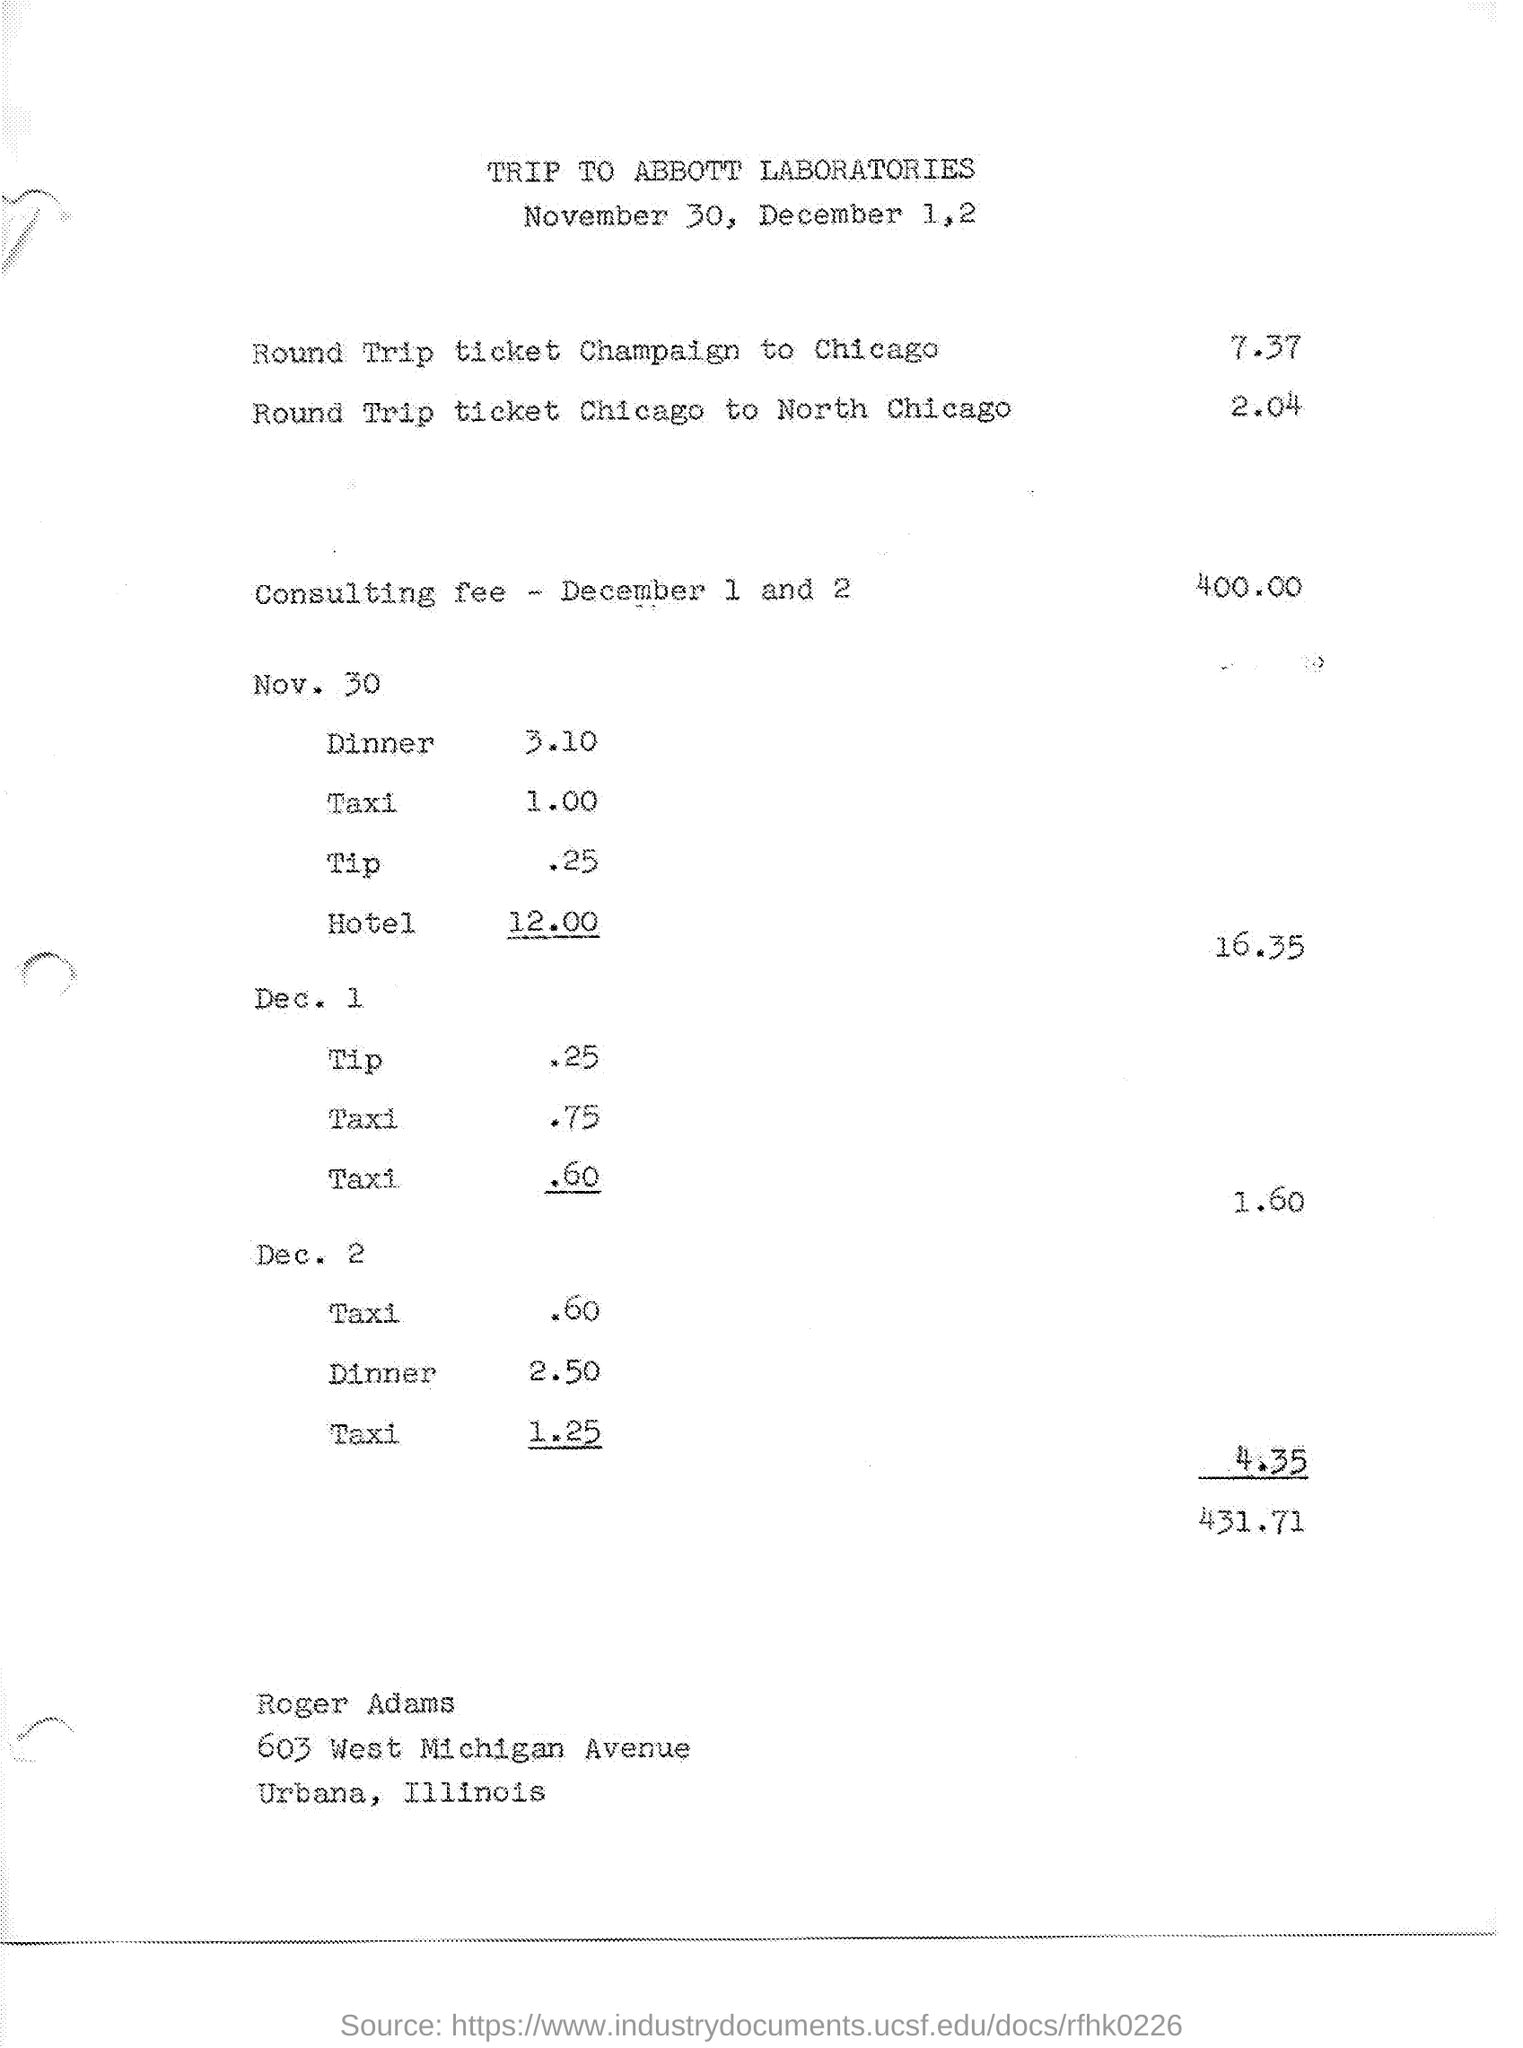Draw attention to some important aspects in this diagram. On November 30th, the total expenses were 16.35 dollars. On November 30, the cost of the hotel was 12.00. The total expenses on December 2 were 4.35. On December 2, the cost of a taxi was approximately 60 cents. On December 2, the cost of dinner was 2.50. 